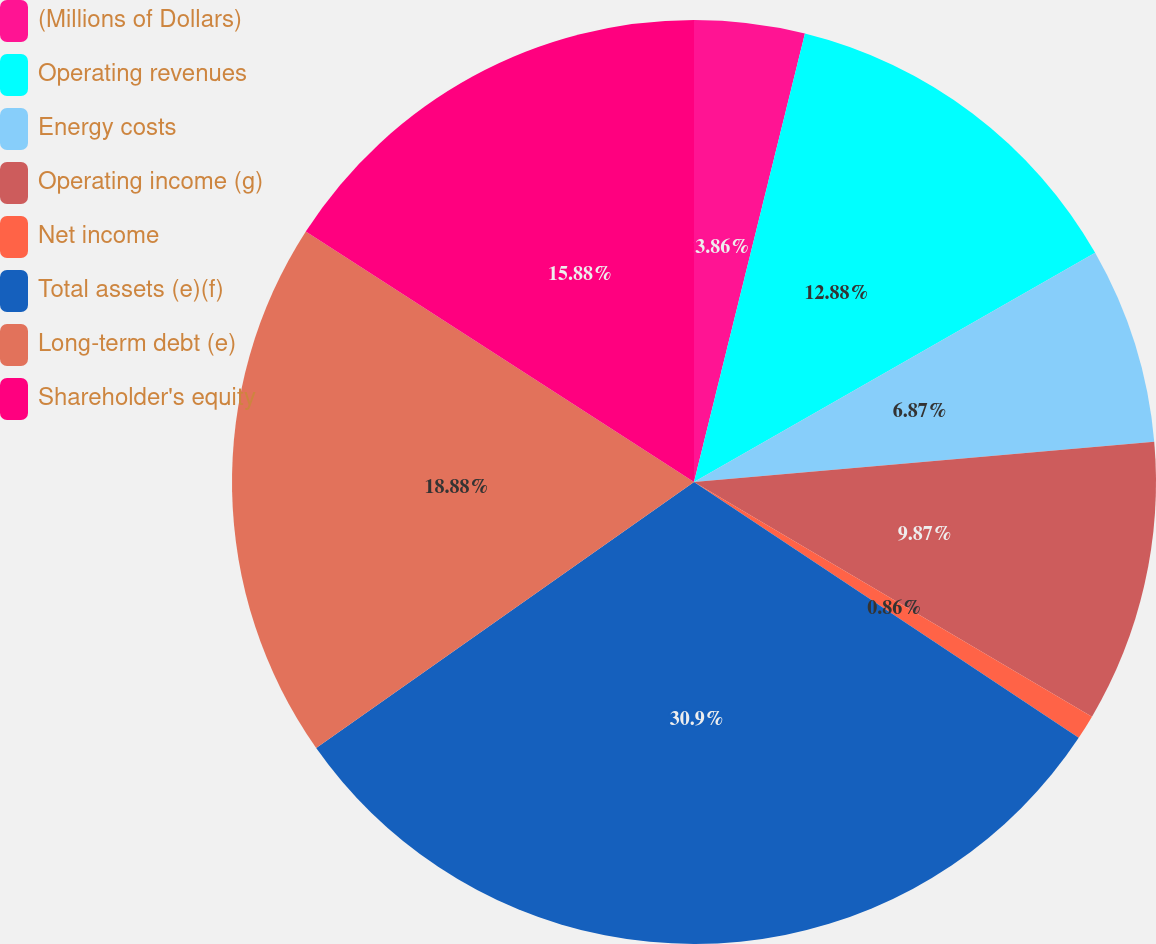Convert chart. <chart><loc_0><loc_0><loc_500><loc_500><pie_chart><fcel>(Millions of Dollars)<fcel>Operating revenues<fcel>Energy costs<fcel>Operating income (g)<fcel>Net income<fcel>Total assets (e)(f)<fcel>Long-term debt (e)<fcel>Shareholder's equity<nl><fcel>3.86%<fcel>12.88%<fcel>6.87%<fcel>9.87%<fcel>0.86%<fcel>30.9%<fcel>18.88%<fcel>15.88%<nl></chart> 